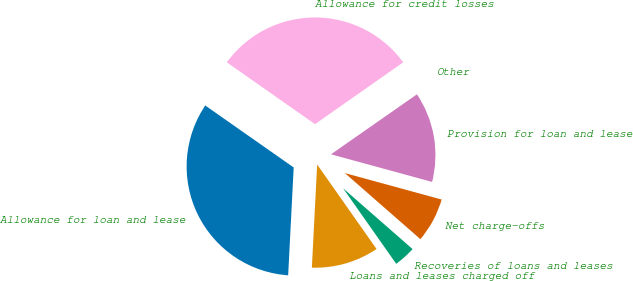Convert chart. <chart><loc_0><loc_0><loc_500><loc_500><pie_chart><fcel>Allowance for loan and lease<fcel>Loans and leases charged off<fcel>Recoveries of loans and leases<fcel>Net charge-offs<fcel>Provision for loan and lease<fcel>Other<fcel>Allowance for credit losses<nl><fcel>33.91%<fcel>10.57%<fcel>3.81%<fcel>7.19%<fcel>13.94%<fcel>0.03%<fcel>30.54%<nl></chart> 